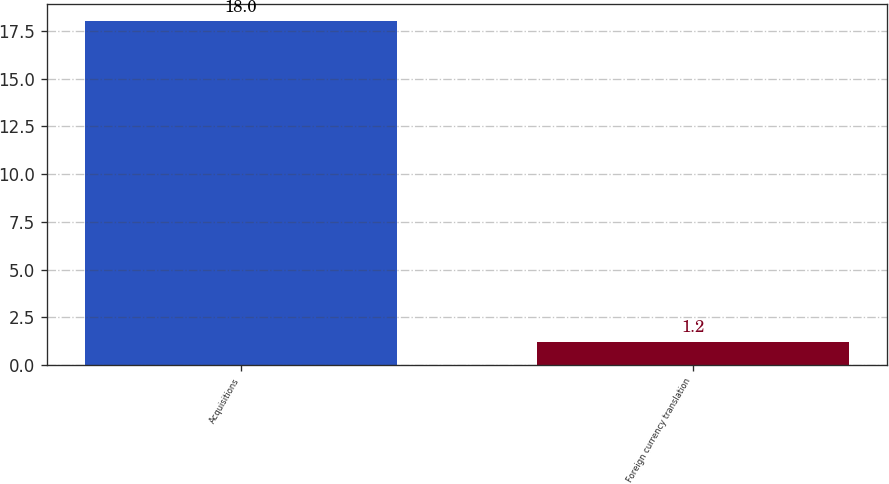<chart> <loc_0><loc_0><loc_500><loc_500><bar_chart><fcel>Acquisitions<fcel>Foreign currency translation<nl><fcel>18<fcel>1.2<nl></chart> 